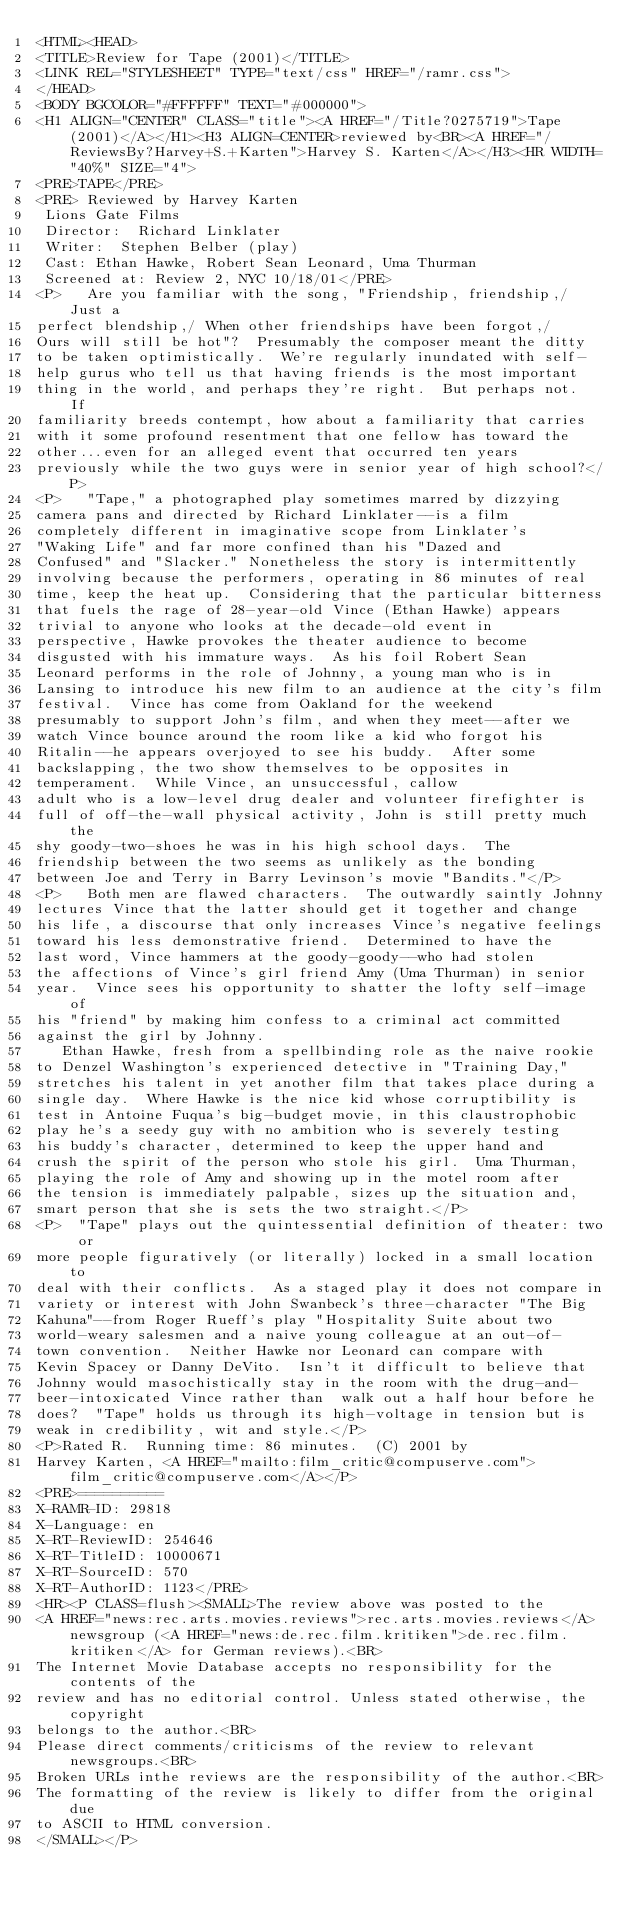<code> <loc_0><loc_0><loc_500><loc_500><_HTML_><HTML><HEAD>
<TITLE>Review for Tape (2001)</TITLE>
<LINK REL="STYLESHEET" TYPE="text/css" HREF="/ramr.css">
</HEAD>
<BODY BGCOLOR="#FFFFFF" TEXT="#000000">
<H1 ALIGN="CENTER" CLASS="title"><A HREF="/Title?0275719">Tape (2001)</A></H1><H3 ALIGN=CENTER>reviewed by<BR><A HREF="/ReviewsBy?Harvey+S.+Karten">Harvey S. Karten</A></H3><HR WIDTH="40%" SIZE="4">
<PRE>TAPE</PRE>
<PRE> Reviewed by Harvey Karten
 Lions Gate Films
 Director:  Richard Linklater
 Writer:  Stephen Belber (play)
 Cast: Ethan Hawke, Robert Sean Leonard, Uma Thurman
 Screened at: Review 2, NYC 10/18/01</PRE>
<P>   Are you familiar with the song, "Friendship, friendship,/ Just a
perfect blendship,/ When other friendships have been forgot,/
Ours will still be hot"?  Presumably the composer meant the ditty
to be taken optimistically.  We're regularly inundated with self-
help gurus who tell us that having friends is the most important
thing in the world, and perhaps they're right.  But perhaps not.  If
familiarity breeds contempt, how about a familiarity that carries
with it some profound resentment that one fellow has toward the
other...even for an alleged event that occurred ten years
previously while the two guys were in senior year of high school?</P>
<P>   "Tape," a photographed play sometimes marred by dizzying
camera pans and directed by Richard Linklater--is a film
completely different in imaginative scope from Linklater's
"Waking Life" and far more confined than his "Dazed and
Confused" and "Slacker." Nonetheless the story is intermittently
involving because the performers, operating in 86 minutes of real
time, keep the heat up.  Considering that the particular bitterness
that fuels the rage of 28-year-old Vince (Ethan Hawke) appears
trivial to anyone who looks at the decade-old event in
perspective, Hawke provokes the theater audience to become
disgusted with his immature ways.  As his foil Robert Sean
Leonard performs in the role of Johnny, a young man who is in
Lansing to introduce his new film to an audience at the city's film
festival.  Vince has come from Oakland for the weekend
presumably to support John's film, and when they meet--after we
watch Vince bounce around the room like a kid who forgot his
Ritalin--he appears overjoyed to see his buddy.  After some
backslapping, the two show themselves to be opposites in
temperament.  While Vince, an unsuccessful, callow
adult who is a low-level drug dealer and volunteer firefighter is
full of off-the-wall physical activity, John is still pretty much the
shy goody-two-shoes he was in his high school days.  The
friendship between the two seems as unlikely as the bonding
between Joe and Terry in Barry Levinson's movie "Bandits."</P>
<P>   Both men are flawed characters.  The outwardly saintly Johnny
lectures Vince that the latter should get it together and change
his life, a discourse that only increases Vince's negative feelings
toward his less demonstrative friend.  Determined to have the
last word, Vince hammers at the goody-goody--who had stolen
the affections of Vince's girl friend Amy (Uma Thurman) in senior
year.  Vince sees his opportunity to shatter the lofty self-image of
his "friend" by making him confess to a criminal act committed
against the girl by Johnny.
   Ethan Hawke, fresh from a spellbinding role as the naive rookie
to Denzel Washington's experienced detective in "Training Day,"
stretches his talent in yet another film that takes place during a
single day.  Where Hawke is the nice kid whose corruptibility is
test in Antoine Fuqua's big-budget movie, in this claustrophobic
play he's a seedy guy with no ambition who is severely testing
his buddy's character, determined to keep the upper hand and
crush the spirit of the person who stole his girl.  Uma Thurman,
playing the role of Amy and showing up in the motel room after
the tension is immediately palpable, sizes up the situation and,
smart person that she is sets the two straight.</P>
<P>  "Tape" plays out the quintessential definition of theater: two or
more people figuratively (or literally) locked in a small location to
deal with their conflicts.  As a staged play it does not compare in
variety or interest with John Swanbeck's three-character "The Big
Kahuna"--from Roger Rueff's play "Hospitality Suite about two
world-weary salesmen and a naive young colleague at an out-of-
town convention.  Neither Hawke nor Leonard can compare with
Kevin Spacey or Danny DeVito.  Isn't it difficult to believe that
Johnny would masochistically stay in the room with the drug-and-
beer-intoxicated Vince rather than  walk out a half hour before he
does?  "Tape" holds us through its high-voltage in tension but is
weak in credibility, wit and style.</P>
<P>Rated R.  Running time: 86 minutes.  (C) 2001 by
Harvey Karten, <A HREF="mailto:film_critic@compuserve.com">film_critic@compuserve.com</A></P>
<PRE>==========
X-RAMR-ID: 29818
X-Language: en
X-RT-ReviewID: 254646
X-RT-TitleID: 10000671
X-RT-SourceID: 570
X-RT-AuthorID: 1123</PRE>
<HR><P CLASS=flush><SMALL>The review above was posted to the
<A HREF="news:rec.arts.movies.reviews">rec.arts.movies.reviews</A> newsgroup (<A HREF="news:de.rec.film.kritiken">de.rec.film.kritiken</A> for German reviews).<BR>
The Internet Movie Database accepts no responsibility for the contents of the
review and has no editorial control. Unless stated otherwise, the copyright
belongs to the author.<BR>
Please direct comments/criticisms of the review to relevant newsgroups.<BR>
Broken URLs inthe reviews are the responsibility of the author.<BR>
The formatting of the review is likely to differ from the original due
to ASCII to HTML conversion.
</SMALL></P></code> 